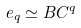<formula> <loc_0><loc_0><loc_500><loc_500>e _ { q } \simeq B C ^ { q }</formula> 